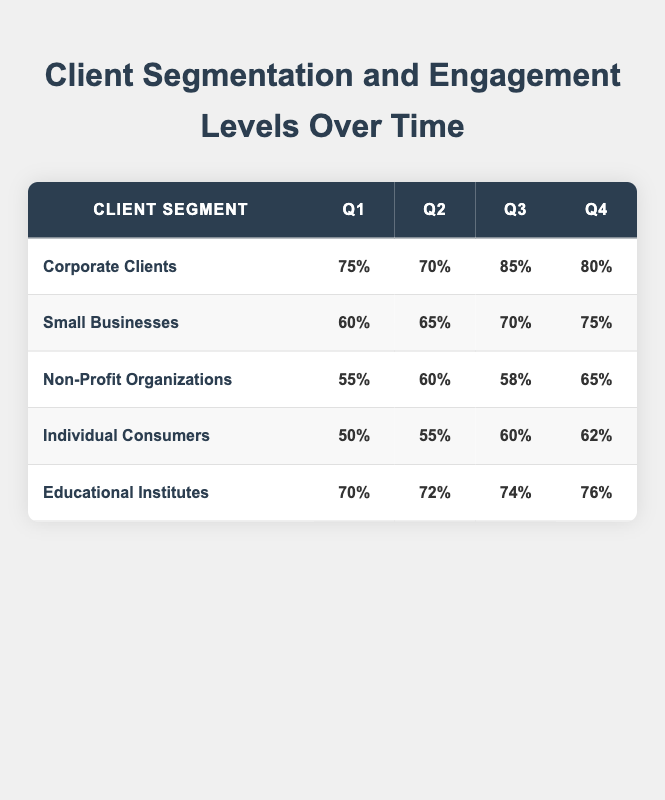What is the engagement level of Corporate Clients in Q3? According to the table, the engagement level for Corporate Clients in Q3 is 85%.
Answer: 85% Which segment had the lowest engagement level in Q1? In Q1, the engagement levels are 75% for Corporate Clients, 60% for Small Businesses, 55% for Non-Profit Organizations, 50% for Individual Consumers, and 70% for Educational Institutes. The lowest level is 50% for Individual Consumers.
Answer: Individual Consumers What was the engagement level change from Q1 to Q4 for Small Businesses? The engagement level in Q1 for Small Businesses is 60% and in Q4 it is 75%. The change is calculated as 75% - 60% = 15%.
Answer: 15% Is the engagement level of Non-Profit Organizations higher in Q4 than in Q3? In Q4 the engagement level for Non-Profit Organizations is 65%, and in Q3 it is 58%. Since 65% is greater than 58%, the answer is yes.
Answer: Yes What is the average engagement level for Educational Institutes across all quarters? The engagement levels for Educational Institutes are 70%, 72%, 74%, and 76%. Adding them gives 70 + 72 + 74 + 76 = 292. There are 4 quarters, so the average is 292 / 4 = 73.
Answer: 73 Which segment saw the greatest increase in engagement from Q2 to Q3? The engagement increases from Q2 to Q3 are as follows: Corporate Clients: 85% - 70% = 15%, Small Businesses: 70% - 65% = 5%, Non-Profit Organizations: 58% - 60% = -2%, Individual Consumers: 60% - 55% = 5%, Educational Institutes: 74% - 72% = 2%. The greatest increase is 15% for Corporate Clients.
Answer: Corporate Clients Was there any segment that experienced a decline in engagement from Q1 to Q2? The engagement levels from Q1 to Q2 are 75% to 70% for Corporate Clients, and 60% to 65% for Small Businesses, 55% to 60% for Non-Profit Organizations, 50% to 55% for Individual Consumers, and 70% to 72% for Educational Institutes. Corporate Clients is the only segment that experienced a decline.
Answer: Yes What is the total engagement level across all segments in Q4? The engagement levels in Q4 are 80% for Corporate Clients, 75% for Small Businesses, 65% for Non-Profit Organizations, 62% for Individual Consumers, and 76% for Educational Institutes. Adding these gives 80 + 75 + 65 + 62 + 76 = 358.
Answer: 358 